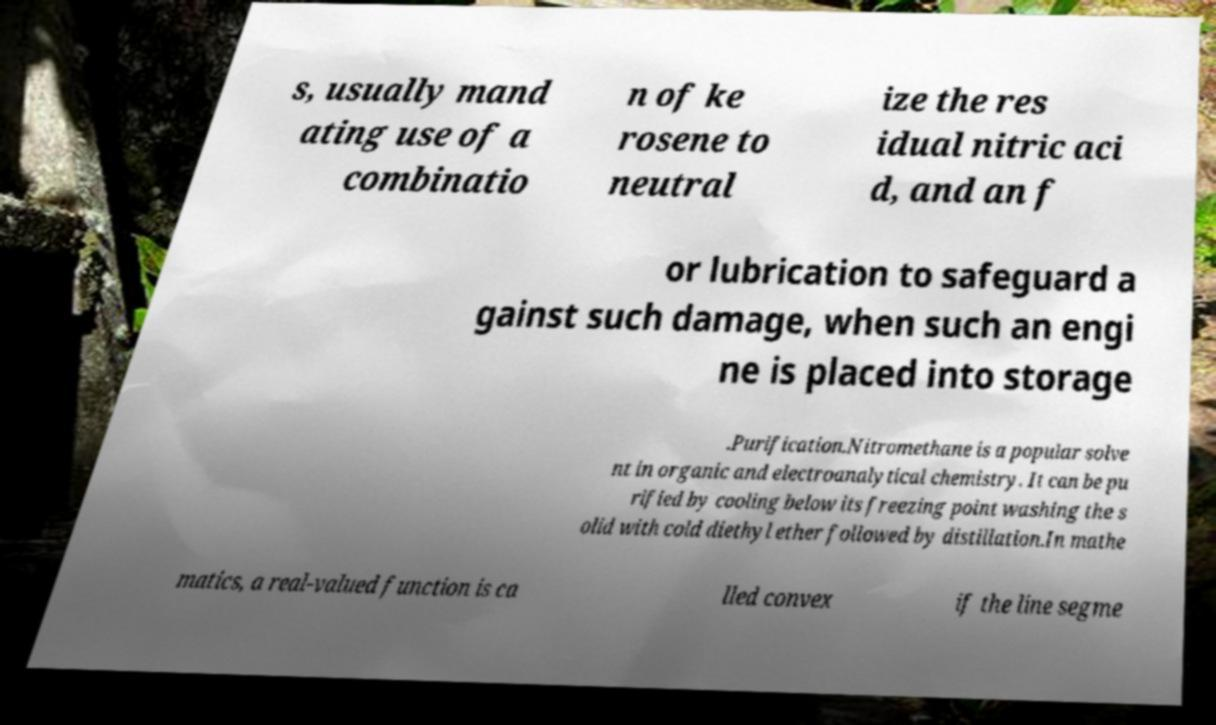There's text embedded in this image that I need extracted. Can you transcribe it verbatim? s, usually mand ating use of a combinatio n of ke rosene to neutral ize the res idual nitric aci d, and an f or lubrication to safeguard a gainst such damage, when such an engi ne is placed into storage .Purification.Nitromethane is a popular solve nt in organic and electroanalytical chemistry. It can be pu rified by cooling below its freezing point washing the s olid with cold diethyl ether followed by distillation.In mathe matics, a real-valued function is ca lled convex if the line segme 